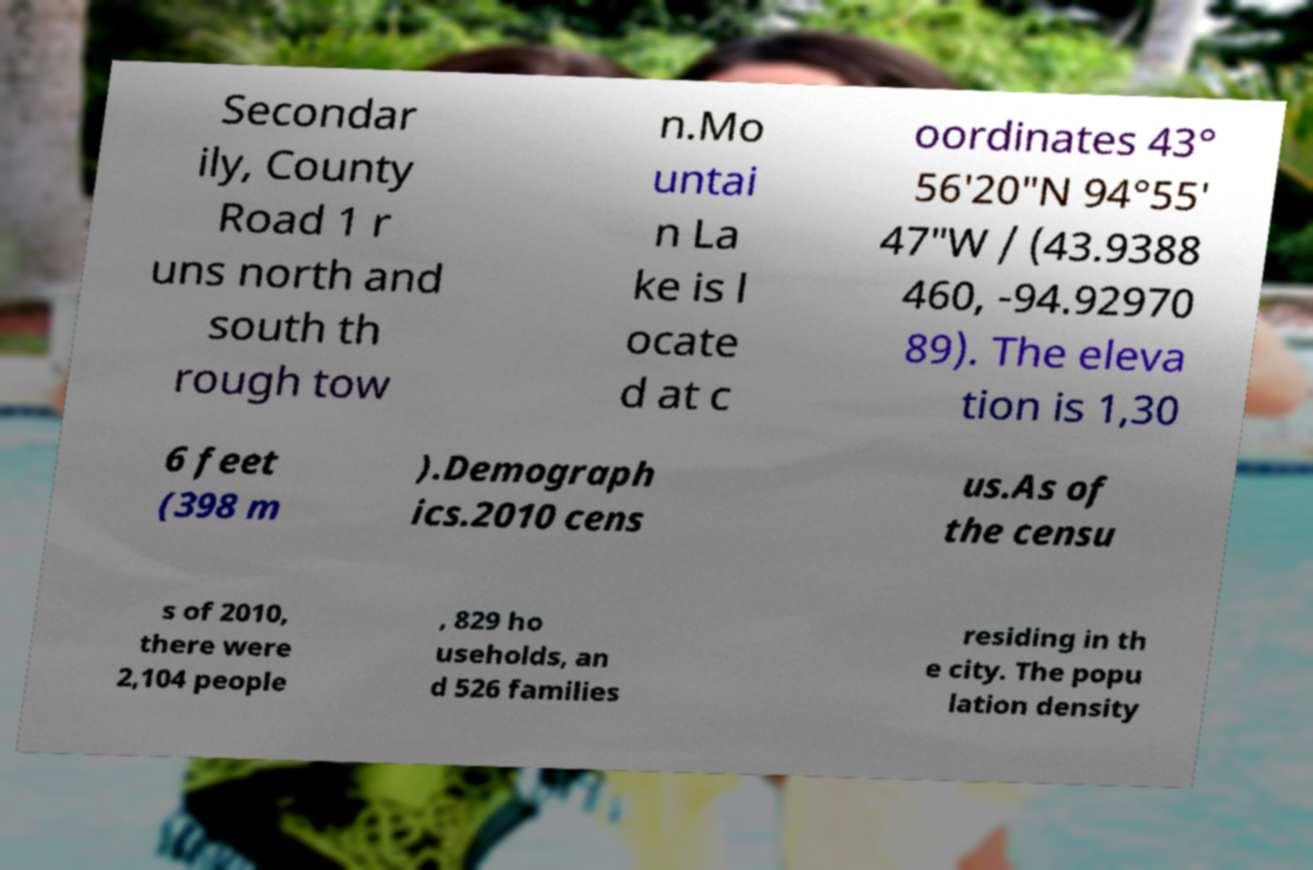There's text embedded in this image that I need extracted. Can you transcribe it verbatim? Secondar ily, County Road 1 r uns north and south th rough tow n.Mo untai n La ke is l ocate d at c oordinates 43° 56′20″N 94°55′ 47″W / (43.9388 460, -94.92970 89). The eleva tion is 1,30 6 feet (398 m ).Demograph ics.2010 cens us.As of the censu s of 2010, there were 2,104 people , 829 ho useholds, an d 526 families residing in th e city. The popu lation density 